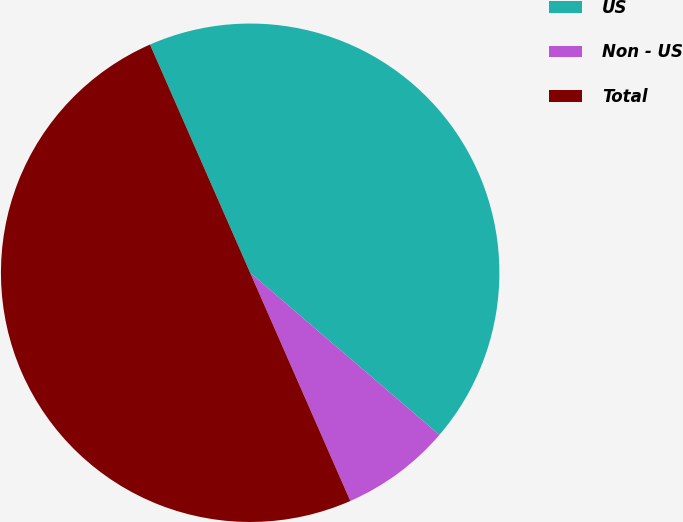Convert chart. <chart><loc_0><loc_0><loc_500><loc_500><pie_chart><fcel>US<fcel>Non - US<fcel>Total<nl><fcel>42.86%<fcel>7.14%<fcel>50.0%<nl></chart> 